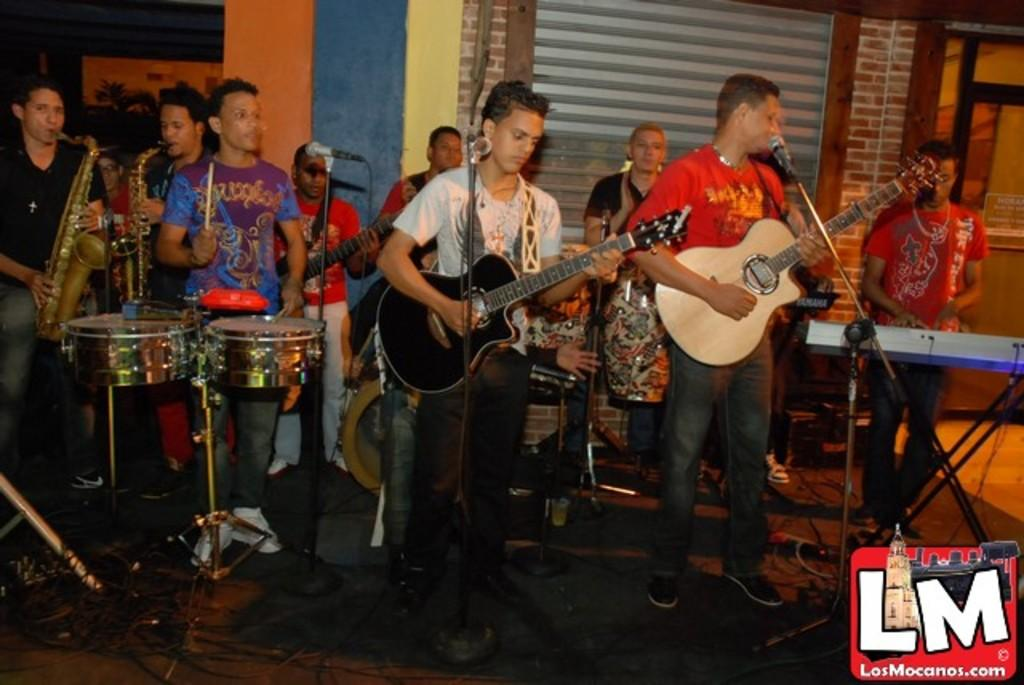What is happening in the image involving a group of people? In the image, there is a group of people standing and playing musical instruments. What objects can be seen in the image related to the people playing music? There is a microphone (mic) in the image. How many rabbits are visible in the image? There are no rabbits present in the image. What type of process is being requested by the people in the image? There is no indication in the image that a process is being requested by the people. 